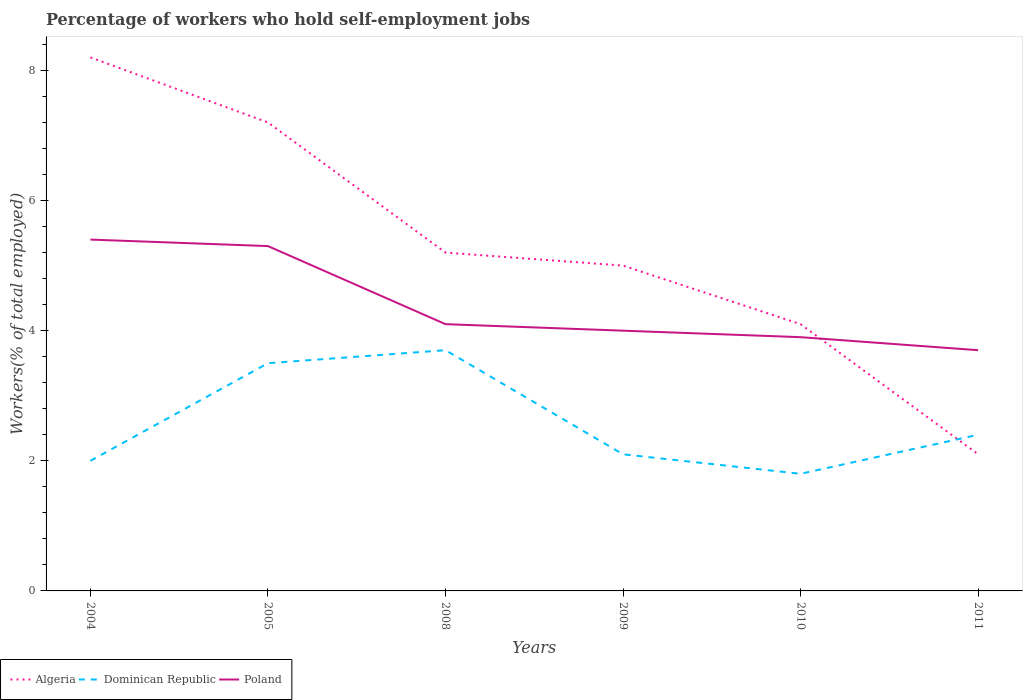Does the line corresponding to Dominican Republic intersect with the line corresponding to Algeria?
Provide a short and direct response. Yes. Is the number of lines equal to the number of legend labels?
Make the answer very short. Yes. Across all years, what is the maximum percentage of self-employed workers in Poland?
Provide a short and direct response. 3.7. In which year was the percentage of self-employed workers in Algeria maximum?
Your response must be concise. 2011. What is the total percentage of self-employed workers in Poland in the graph?
Your response must be concise. 1.2. What is the difference between the highest and the second highest percentage of self-employed workers in Algeria?
Offer a terse response. 6.1. How many lines are there?
Make the answer very short. 3. Does the graph contain grids?
Keep it short and to the point. No. What is the title of the graph?
Your answer should be very brief. Percentage of workers who hold self-employment jobs. Does "Israel" appear as one of the legend labels in the graph?
Give a very brief answer. No. What is the label or title of the X-axis?
Give a very brief answer. Years. What is the label or title of the Y-axis?
Keep it short and to the point. Workers(% of total employed). What is the Workers(% of total employed) in Algeria in 2004?
Your answer should be very brief. 8.2. What is the Workers(% of total employed) of Dominican Republic in 2004?
Keep it short and to the point. 2. What is the Workers(% of total employed) of Poland in 2004?
Offer a terse response. 5.4. What is the Workers(% of total employed) in Algeria in 2005?
Ensure brevity in your answer.  7.2. What is the Workers(% of total employed) in Poland in 2005?
Your answer should be compact. 5.3. What is the Workers(% of total employed) in Algeria in 2008?
Your response must be concise. 5.2. What is the Workers(% of total employed) in Dominican Republic in 2008?
Give a very brief answer. 3.7. What is the Workers(% of total employed) in Poland in 2008?
Ensure brevity in your answer.  4.1. What is the Workers(% of total employed) of Algeria in 2009?
Give a very brief answer. 5. What is the Workers(% of total employed) in Dominican Republic in 2009?
Make the answer very short. 2.1. What is the Workers(% of total employed) in Algeria in 2010?
Ensure brevity in your answer.  4.1. What is the Workers(% of total employed) of Dominican Republic in 2010?
Your answer should be compact. 1.8. What is the Workers(% of total employed) in Poland in 2010?
Keep it short and to the point. 3.9. What is the Workers(% of total employed) in Algeria in 2011?
Keep it short and to the point. 2.1. What is the Workers(% of total employed) of Dominican Republic in 2011?
Ensure brevity in your answer.  2.4. What is the Workers(% of total employed) in Poland in 2011?
Make the answer very short. 3.7. Across all years, what is the maximum Workers(% of total employed) in Algeria?
Give a very brief answer. 8.2. Across all years, what is the maximum Workers(% of total employed) of Dominican Republic?
Your answer should be compact. 3.7. Across all years, what is the maximum Workers(% of total employed) of Poland?
Your answer should be compact. 5.4. Across all years, what is the minimum Workers(% of total employed) of Algeria?
Offer a terse response. 2.1. Across all years, what is the minimum Workers(% of total employed) in Dominican Republic?
Your response must be concise. 1.8. Across all years, what is the minimum Workers(% of total employed) in Poland?
Offer a terse response. 3.7. What is the total Workers(% of total employed) of Algeria in the graph?
Your answer should be very brief. 31.8. What is the total Workers(% of total employed) of Poland in the graph?
Keep it short and to the point. 26.4. What is the difference between the Workers(% of total employed) of Algeria in 2004 and that in 2005?
Ensure brevity in your answer.  1. What is the difference between the Workers(% of total employed) in Dominican Republic in 2004 and that in 2005?
Your answer should be very brief. -1.5. What is the difference between the Workers(% of total employed) of Algeria in 2004 and that in 2009?
Provide a succinct answer. 3.2. What is the difference between the Workers(% of total employed) of Dominican Republic in 2004 and that in 2009?
Make the answer very short. -0.1. What is the difference between the Workers(% of total employed) in Poland in 2004 and that in 2009?
Provide a short and direct response. 1.4. What is the difference between the Workers(% of total employed) in Algeria in 2004 and that in 2011?
Give a very brief answer. 6.1. What is the difference between the Workers(% of total employed) of Poland in 2004 and that in 2011?
Ensure brevity in your answer.  1.7. What is the difference between the Workers(% of total employed) in Poland in 2005 and that in 2008?
Make the answer very short. 1.2. What is the difference between the Workers(% of total employed) of Algeria in 2005 and that in 2009?
Give a very brief answer. 2.2. What is the difference between the Workers(% of total employed) of Dominican Republic in 2005 and that in 2009?
Give a very brief answer. 1.4. What is the difference between the Workers(% of total employed) of Poland in 2005 and that in 2009?
Your answer should be compact. 1.3. What is the difference between the Workers(% of total employed) in Algeria in 2005 and that in 2010?
Offer a very short reply. 3.1. What is the difference between the Workers(% of total employed) in Poland in 2005 and that in 2011?
Ensure brevity in your answer.  1.6. What is the difference between the Workers(% of total employed) in Dominican Republic in 2008 and that in 2009?
Keep it short and to the point. 1.6. What is the difference between the Workers(% of total employed) in Algeria in 2008 and that in 2010?
Give a very brief answer. 1.1. What is the difference between the Workers(% of total employed) of Dominican Republic in 2008 and that in 2010?
Offer a terse response. 1.9. What is the difference between the Workers(% of total employed) of Poland in 2008 and that in 2010?
Your answer should be very brief. 0.2. What is the difference between the Workers(% of total employed) in Poland in 2008 and that in 2011?
Provide a short and direct response. 0.4. What is the difference between the Workers(% of total employed) in Algeria in 2009 and that in 2010?
Your answer should be compact. 0.9. What is the difference between the Workers(% of total employed) in Dominican Republic in 2009 and that in 2011?
Give a very brief answer. -0.3. What is the difference between the Workers(% of total employed) of Poland in 2009 and that in 2011?
Your response must be concise. 0.3. What is the difference between the Workers(% of total employed) in Algeria in 2004 and the Workers(% of total employed) in Dominican Republic in 2005?
Ensure brevity in your answer.  4.7. What is the difference between the Workers(% of total employed) in Algeria in 2004 and the Workers(% of total employed) in Dominican Republic in 2008?
Keep it short and to the point. 4.5. What is the difference between the Workers(% of total employed) in Algeria in 2004 and the Workers(% of total employed) in Poland in 2008?
Your answer should be compact. 4.1. What is the difference between the Workers(% of total employed) of Dominican Republic in 2004 and the Workers(% of total employed) of Poland in 2009?
Ensure brevity in your answer.  -2. What is the difference between the Workers(% of total employed) of Algeria in 2004 and the Workers(% of total employed) of Dominican Republic in 2010?
Give a very brief answer. 6.4. What is the difference between the Workers(% of total employed) in Dominican Republic in 2004 and the Workers(% of total employed) in Poland in 2010?
Offer a very short reply. -1.9. What is the difference between the Workers(% of total employed) in Algeria in 2004 and the Workers(% of total employed) in Dominican Republic in 2011?
Your answer should be very brief. 5.8. What is the difference between the Workers(% of total employed) of Dominican Republic in 2004 and the Workers(% of total employed) of Poland in 2011?
Offer a terse response. -1.7. What is the difference between the Workers(% of total employed) of Dominican Republic in 2005 and the Workers(% of total employed) of Poland in 2008?
Provide a short and direct response. -0.6. What is the difference between the Workers(% of total employed) in Algeria in 2005 and the Workers(% of total employed) in Poland in 2009?
Provide a succinct answer. 3.2. What is the difference between the Workers(% of total employed) in Dominican Republic in 2005 and the Workers(% of total employed) in Poland in 2009?
Your answer should be compact. -0.5. What is the difference between the Workers(% of total employed) in Algeria in 2005 and the Workers(% of total employed) in Dominican Republic in 2011?
Offer a very short reply. 4.8. What is the difference between the Workers(% of total employed) in Algeria in 2008 and the Workers(% of total employed) in Dominican Republic in 2009?
Make the answer very short. 3.1. What is the difference between the Workers(% of total employed) in Dominican Republic in 2008 and the Workers(% of total employed) in Poland in 2009?
Your response must be concise. -0.3. What is the difference between the Workers(% of total employed) in Algeria in 2008 and the Workers(% of total employed) in Dominican Republic in 2010?
Your answer should be very brief. 3.4. What is the difference between the Workers(% of total employed) in Algeria in 2008 and the Workers(% of total employed) in Poland in 2010?
Your response must be concise. 1.3. What is the difference between the Workers(% of total employed) of Algeria in 2008 and the Workers(% of total employed) of Dominican Republic in 2011?
Offer a very short reply. 2.8. What is the difference between the Workers(% of total employed) of Algeria in 2008 and the Workers(% of total employed) of Poland in 2011?
Ensure brevity in your answer.  1.5. What is the difference between the Workers(% of total employed) in Algeria in 2009 and the Workers(% of total employed) in Poland in 2010?
Offer a very short reply. 1.1. What is the difference between the Workers(% of total employed) in Algeria in 2010 and the Workers(% of total employed) in Dominican Republic in 2011?
Offer a very short reply. 1.7. What is the average Workers(% of total employed) of Algeria per year?
Your answer should be compact. 5.3. What is the average Workers(% of total employed) of Dominican Republic per year?
Make the answer very short. 2.58. In the year 2004, what is the difference between the Workers(% of total employed) of Algeria and Workers(% of total employed) of Poland?
Give a very brief answer. 2.8. In the year 2004, what is the difference between the Workers(% of total employed) of Dominican Republic and Workers(% of total employed) of Poland?
Provide a succinct answer. -3.4. In the year 2008, what is the difference between the Workers(% of total employed) in Algeria and Workers(% of total employed) in Poland?
Offer a terse response. 1.1. In the year 2008, what is the difference between the Workers(% of total employed) of Dominican Republic and Workers(% of total employed) of Poland?
Ensure brevity in your answer.  -0.4. In the year 2009, what is the difference between the Workers(% of total employed) in Algeria and Workers(% of total employed) in Dominican Republic?
Provide a short and direct response. 2.9. In the year 2010, what is the difference between the Workers(% of total employed) of Algeria and Workers(% of total employed) of Dominican Republic?
Provide a succinct answer. 2.3. In the year 2010, what is the difference between the Workers(% of total employed) in Dominican Republic and Workers(% of total employed) in Poland?
Give a very brief answer. -2.1. In the year 2011, what is the difference between the Workers(% of total employed) in Algeria and Workers(% of total employed) in Dominican Republic?
Provide a short and direct response. -0.3. In the year 2011, what is the difference between the Workers(% of total employed) in Algeria and Workers(% of total employed) in Poland?
Give a very brief answer. -1.6. In the year 2011, what is the difference between the Workers(% of total employed) of Dominican Republic and Workers(% of total employed) of Poland?
Your response must be concise. -1.3. What is the ratio of the Workers(% of total employed) of Algeria in 2004 to that in 2005?
Provide a short and direct response. 1.14. What is the ratio of the Workers(% of total employed) in Dominican Republic in 2004 to that in 2005?
Ensure brevity in your answer.  0.57. What is the ratio of the Workers(% of total employed) in Poland in 2004 to that in 2005?
Offer a very short reply. 1.02. What is the ratio of the Workers(% of total employed) in Algeria in 2004 to that in 2008?
Provide a short and direct response. 1.58. What is the ratio of the Workers(% of total employed) in Dominican Republic in 2004 to that in 2008?
Your answer should be compact. 0.54. What is the ratio of the Workers(% of total employed) in Poland in 2004 to that in 2008?
Give a very brief answer. 1.32. What is the ratio of the Workers(% of total employed) in Algeria in 2004 to that in 2009?
Offer a terse response. 1.64. What is the ratio of the Workers(% of total employed) of Poland in 2004 to that in 2009?
Keep it short and to the point. 1.35. What is the ratio of the Workers(% of total employed) in Algeria in 2004 to that in 2010?
Keep it short and to the point. 2. What is the ratio of the Workers(% of total employed) in Poland in 2004 to that in 2010?
Offer a terse response. 1.38. What is the ratio of the Workers(% of total employed) of Algeria in 2004 to that in 2011?
Keep it short and to the point. 3.9. What is the ratio of the Workers(% of total employed) in Dominican Republic in 2004 to that in 2011?
Give a very brief answer. 0.83. What is the ratio of the Workers(% of total employed) in Poland in 2004 to that in 2011?
Your answer should be very brief. 1.46. What is the ratio of the Workers(% of total employed) in Algeria in 2005 to that in 2008?
Provide a succinct answer. 1.38. What is the ratio of the Workers(% of total employed) of Dominican Republic in 2005 to that in 2008?
Your response must be concise. 0.95. What is the ratio of the Workers(% of total employed) of Poland in 2005 to that in 2008?
Provide a succinct answer. 1.29. What is the ratio of the Workers(% of total employed) of Algeria in 2005 to that in 2009?
Give a very brief answer. 1.44. What is the ratio of the Workers(% of total employed) of Dominican Republic in 2005 to that in 2009?
Provide a short and direct response. 1.67. What is the ratio of the Workers(% of total employed) in Poland in 2005 to that in 2009?
Keep it short and to the point. 1.32. What is the ratio of the Workers(% of total employed) of Algeria in 2005 to that in 2010?
Provide a succinct answer. 1.76. What is the ratio of the Workers(% of total employed) in Dominican Republic in 2005 to that in 2010?
Provide a short and direct response. 1.94. What is the ratio of the Workers(% of total employed) of Poland in 2005 to that in 2010?
Your answer should be very brief. 1.36. What is the ratio of the Workers(% of total employed) in Algeria in 2005 to that in 2011?
Give a very brief answer. 3.43. What is the ratio of the Workers(% of total employed) in Dominican Republic in 2005 to that in 2011?
Provide a succinct answer. 1.46. What is the ratio of the Workers(% of total employed) of Poland in 2005 to that in 2011?
Ensure brevity in your answer.  1.43. What is the ratio of the Workers(% of total employed) in Dominican Republic in 2008 to that in 2009?
Your answer should be compact. 1.76. What is the ratio of the Workers(% of total employed) in Poland in 2008 to that in 2009?
Give a very brief answer. 1.02. What is the ratio of the Workers(% of total employed) of Algeria in 2008 to that in 2010?
Your answer should be very brief. 1.27. What is the ratio of the Workers(% of total employed) in Dominican Republic in 2008 to that in 2010?
Provide a short and direct response. 2.06. What is the ratio of the Workers(% of total employed) of Poland in 2008 to that in 2010?
Your answer should be compact. 1.05. What is the ratio of the Workers(% of total employed) of Algeria in 2008 to that in 2011?
Offer a terse response. 2.48. What is the ratio of the Workers(% of total employed) in Dominican Republic in 2008 to that in 2011?
Ensure brevity in your answer.  1.54. What is the ratio of the Workers(% of total employed) of Poland in 2008 to that in 2011?
Your answer should be compact. 1.11. What is the ratio of the Workers(% of total employed) in Algeria in 2009 to that in 2010?
Keep it short and to the point. 1.22. What is the ratio of the Workers(% of total employed) of Poland in 2009 to that in 2010?
Offer a very short reply. 1.03. What is the ratio of the Workers(% of total employed) of Algeria in 2009 to that in 2011?
Provide a short and direct response. 2.38. What is the ratio of the Workers(% of total employed) of Dominican Republic in 2009 to that in 2011?
Your response must be concise. 0.88. What is the ratio of the Workers(% of total employed) in Poland in 2009 to that in 2011?
Your response must be concise. 1.08. What is the ratio of the Workers(% of total employed) of Algeria in 2010 to that in 2011?
Your answer should be very brief. 1.95. What is the ratio of the Workers(% of total employed) of Dominican Republic in 2010 to that in 2011?
Provide a short and direct response. 0.75. What is the ratio of the Workers(% of total employed) of Poland in 2010 to that in 2011?
Offer a terse response. 1.05. What is the difference between the highest and the second highest Workers(% of total employed) of Dominican Republic?
Ensure brevity in your answer.  0.2. What is the difference between the highest and the lowest Workers(% of total employed) in Algeria?
Give a very brief answer. 6.1. 